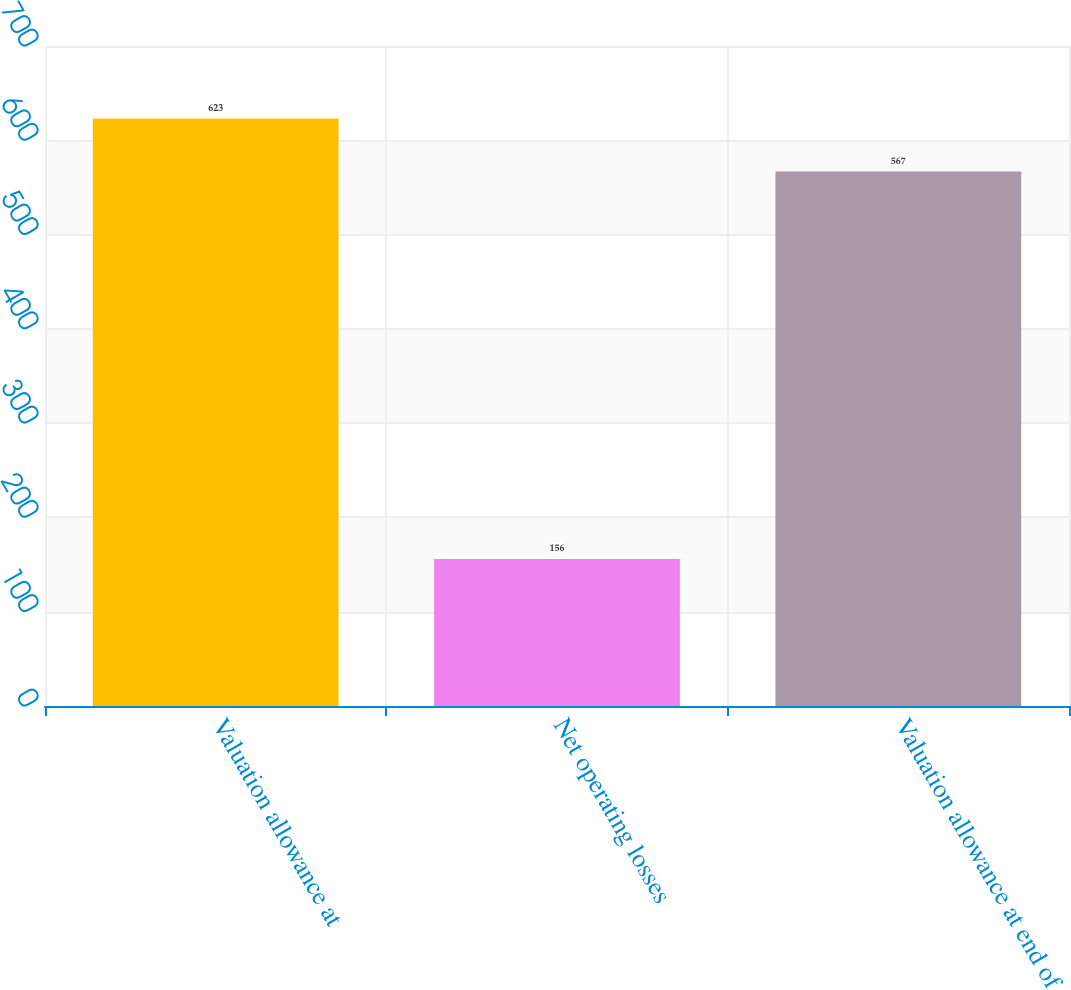Convert chart. <chart><loc_0><loc_0><loc_500><loc_500><bar_chart><fcel>Valuation allowance at<fcel>Net operating losses<fcel>Valuation allowance at end of<nl><fcel>623<fcel>156<fcel>567<nl></chart> 